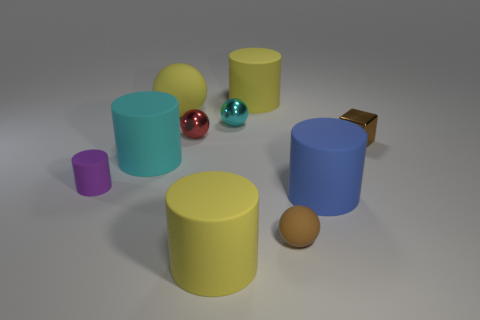There is a tiny brown thing behind the small sphere in front of the tiny purple matte cylinder; what number of brown rubber things are right of it?
Keep it short and to the point. 0. There is a yellow rubber cylinder behind the big blue cylinder; what size is it?
Provide a short and direct response. Large. There is a large yellow matte object to the left of the red object; is it the same shape as the tiny brown matte thing?
Make the answer very short. Yes. There is a large cyan object that is the same shape as the large blue rubber thing; what is its material?
Ensure brevity in your answer.  Rubber. Is there anything else that is the same size as the brown shiny object?
Offer a terse response. Yes. Is there a yellow thing?
Provide a succinct answer. Yes. There is a yellow thing left of the yellow matte cylinder that is on the left side of the large cylinder behind the tiny cyan metallic sphere; what is its material?
Give a very brief answer. Rubber. There is a small purple matte object; is its shape the same as the yellow matte object in front of the large cyan cylinder?
Your answer should be very brief. Yes. What number of tiny purple rubber objects have the same shape as the big cyan thing?
Ensure brevity in your answer.  1. What is the shape of the cyan metal thing?
Provide a short and direct response. Sphere. 